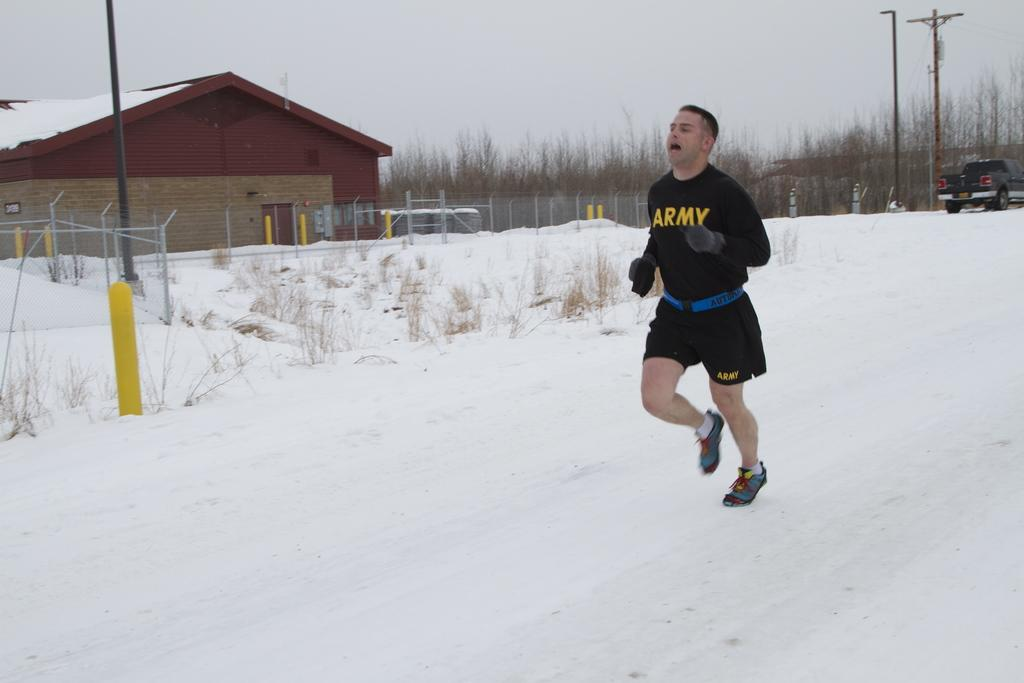Provide a one-sentence caption for the provided image. A man wearing black ARMY clothing jogs in the snow. 